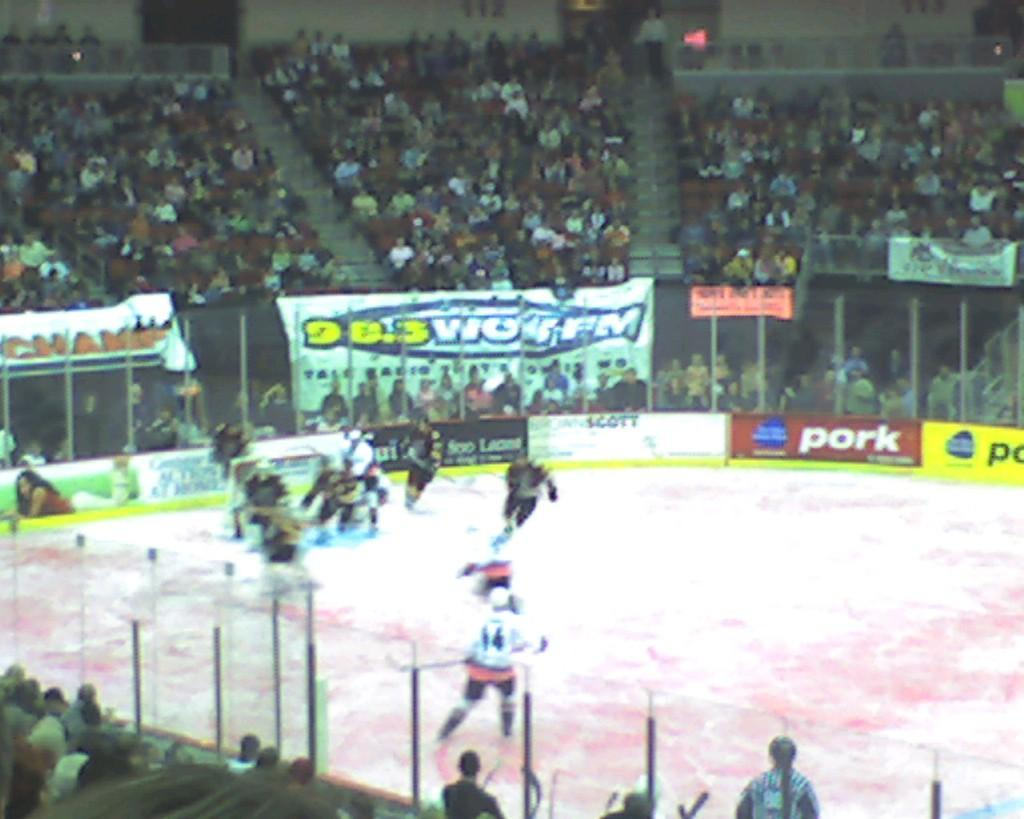<image>
Render a clear and concise summary of the photo. Hockey players are on the ice, with a banner for 98.3 WOIL-FM banner behind the glass. 